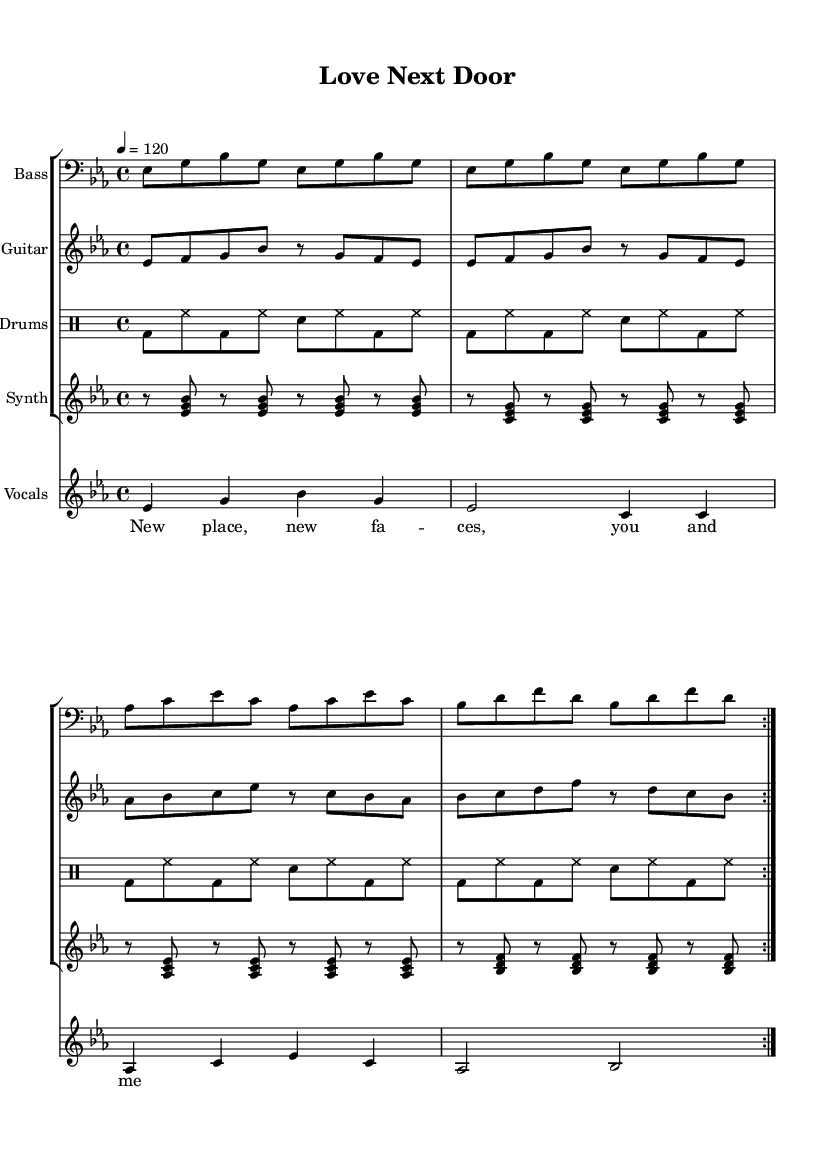What is the key signature of this music? The key signature is indicated by the two flats in the beginning of the staff, which corresponds to the key of B flat major or G minor. In this case, it is B flat major.
Answer: B flat major What is the time signature of this music? The time signature is shown at the beginning of the staff as 4 over 4, meaning there are four beats per measure, and the quarter note receives one beat.
Answer: 4/4 What is the tempo of this music? The tempo marking is provided as a number at the beginning, indicating the speed of the piece. In this case, it is set at 120 beats per minute.
Answer: 120 How many repetitions are indicated for the main sections? The score contains repeat signs, specifically indicating that each main section should be played twice, thus emphasizing the groove characteristic.
Answer: 2 What instrument plays the bass line? The clef for the bass line is notated as a bass clef, specifically indicating that it is played by the bass instrument.
Answer: Bass Which phrase expresses the joy of young love? The lyric section includes text where the mood lit conveys a sense of excitement and happiness, particularly the line "New place, new faces, you and me."
Answer: "New place, new faces, you and me." What feeling does this funk tune generally convey? The overall mood of the tune can be determined by its upbeat tempo, syncopation, and lyrical content, conveying a sense of celebration and joy in young love and cohabitation.
Answer: Joyful 